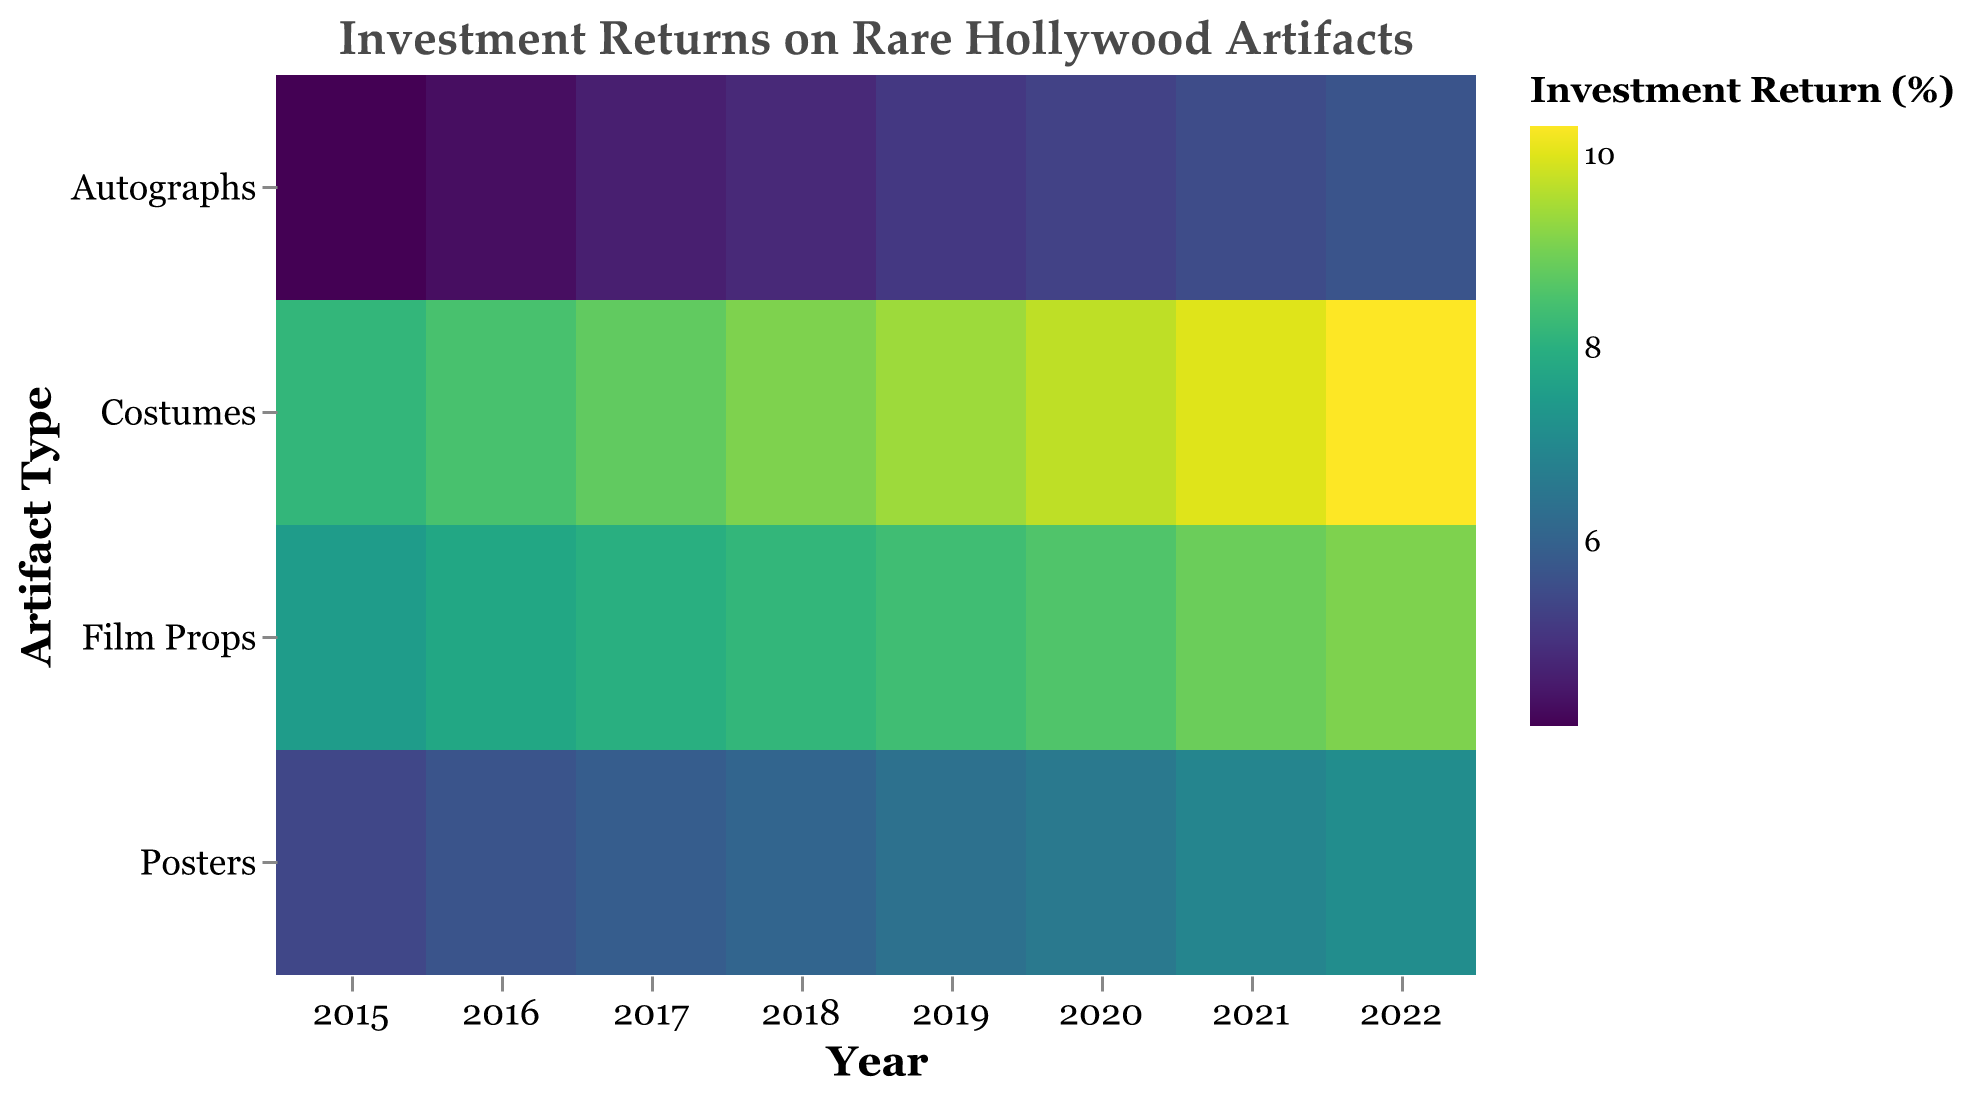What is the title of the heatmap? The title is located at the top of the heatmap and usually provides a brief description of what the heatmap represents. In this case, it reads "Investment Returns on Rare Hollywood Artifacts."
Answer: Investment Returns on Rare Hollywood Artifacts In which year did Film Props have the highest investment return? To find this, look along the 'Film Props' row and identify the cell with the darkest color/ highest value. The year corresponding to this cell is the year with the highest return for Film Props.
Answer: 2022 How did the investment return for Posters change from 2015 to 2022? Locate the 'Posters' row and compare the values from 2015 to 2022. Calculate the difference between these two years' values.
Answer: Increased by 1.7% What was the investment return for Autographs in 2020? Find the 'Autographs' row and look at the value in the column labeled 2020. This value is the investment return for that year.
Answer: 5.3% Which artifact type had the most consistent increase in investment returns from 2015 to 2022? Examine each artifact type's row and observe the trend in the color gradient or numeric values from 2015 to 2022. Determine which type shows a consistent increase without any decreases.
Answer: Costumes Calculate the average investment return for Film Props over the given years. Sum all the investment returns for 'Film Props' from 2015 to 2022, then divide by the number of years (8). (7.5 + 7.8 + 8.0 + 8.2 + 8.4 + 8.6 + 8.9 + 9.1) / 8 = 66.5 / 8
Answer: 8.3% Which artifact type saw the largest percentage increase in investment return from 2015 to 2022? Calculate the percentage increase for each type from 2015 to 2022 [(2022 value - 2015 value) / 2015 value * 100%]. Compare the values to identify the type with the largest increase. Costumes: [(10.3 - 8.2) / 8.2 * 100% = 25.6%]
Answer: Costumes In 2019, which artifact type had the lowest investment return? Inspect the 2019 column and find the cell with the lightest color/ lowest value. The corresponding 'Type' for this cell is the artifact type with the lowest return in 2019.
Answer: Autographs Compare the investment returns of Costumes and Posters in 2021. Which type had a higher return, and by how much? Locate the values for 'Costumes' and 'Posters' in the 2021 column. Subtract the Posters' return from Costumes' return to find the difference. 10.0 - 6.9 = 3.1
Answer: Costumes, 3.1% higher Which year had the highest investment return across all artifact types? Examine all the columns and find the year with the darkest cell in any row, as darker cells represent higher returns.
Answer: 2022 